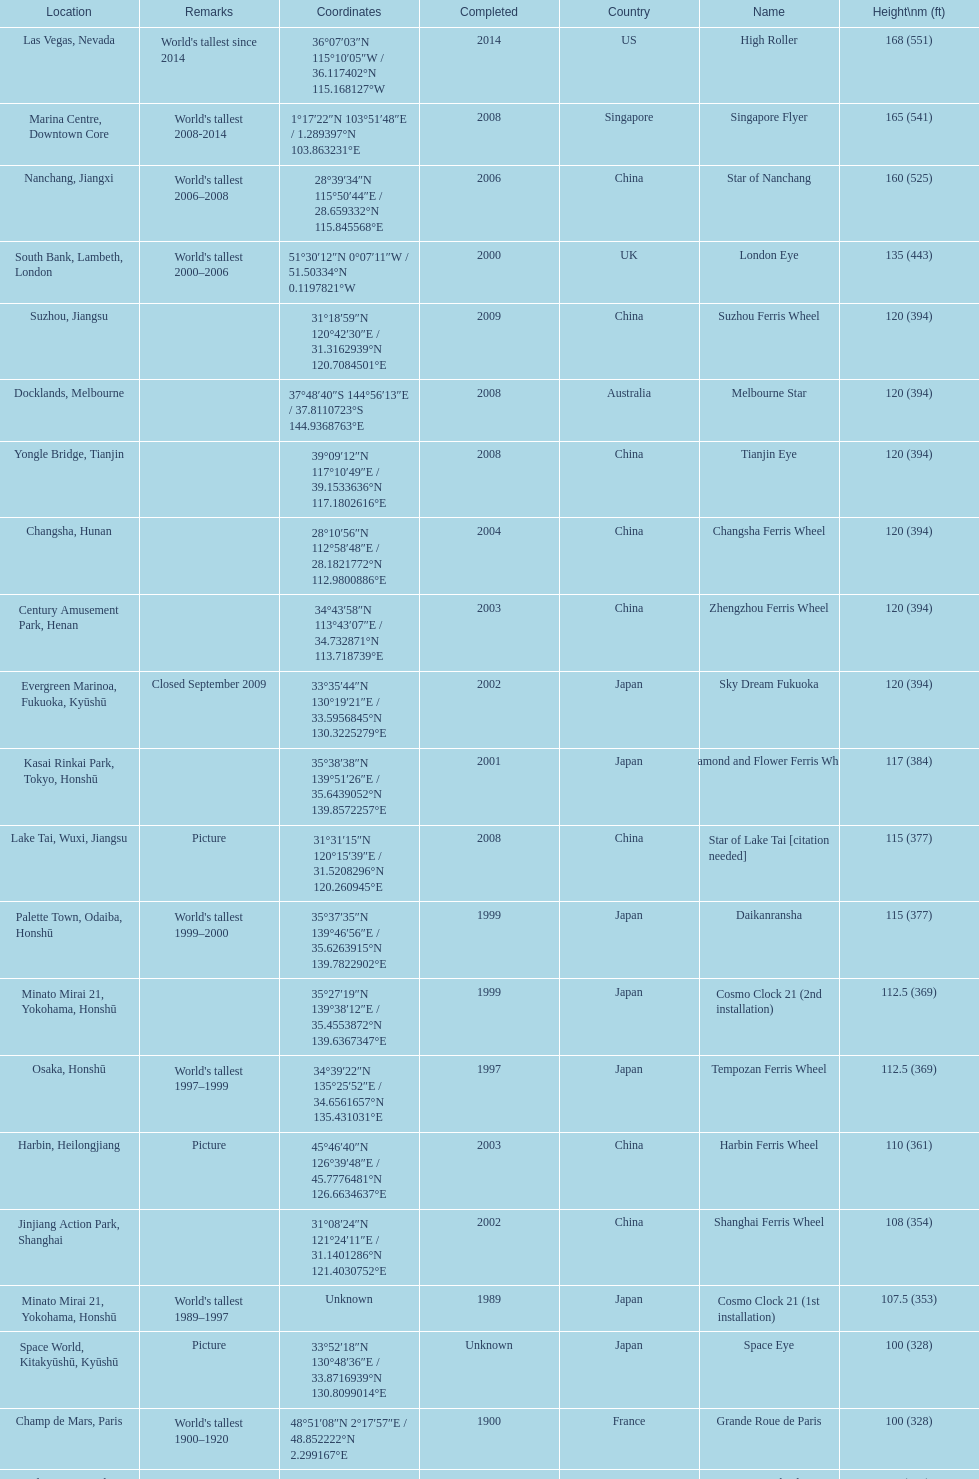Which country had the most roller coasters over 80 feet in height in 2008? China. 